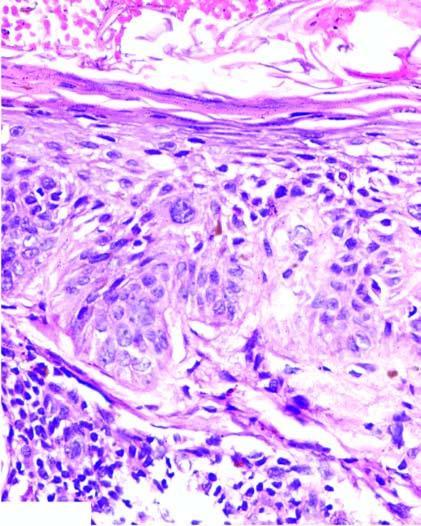what is not breached?
Answer the question using a single word or phrase. Basement membrane 